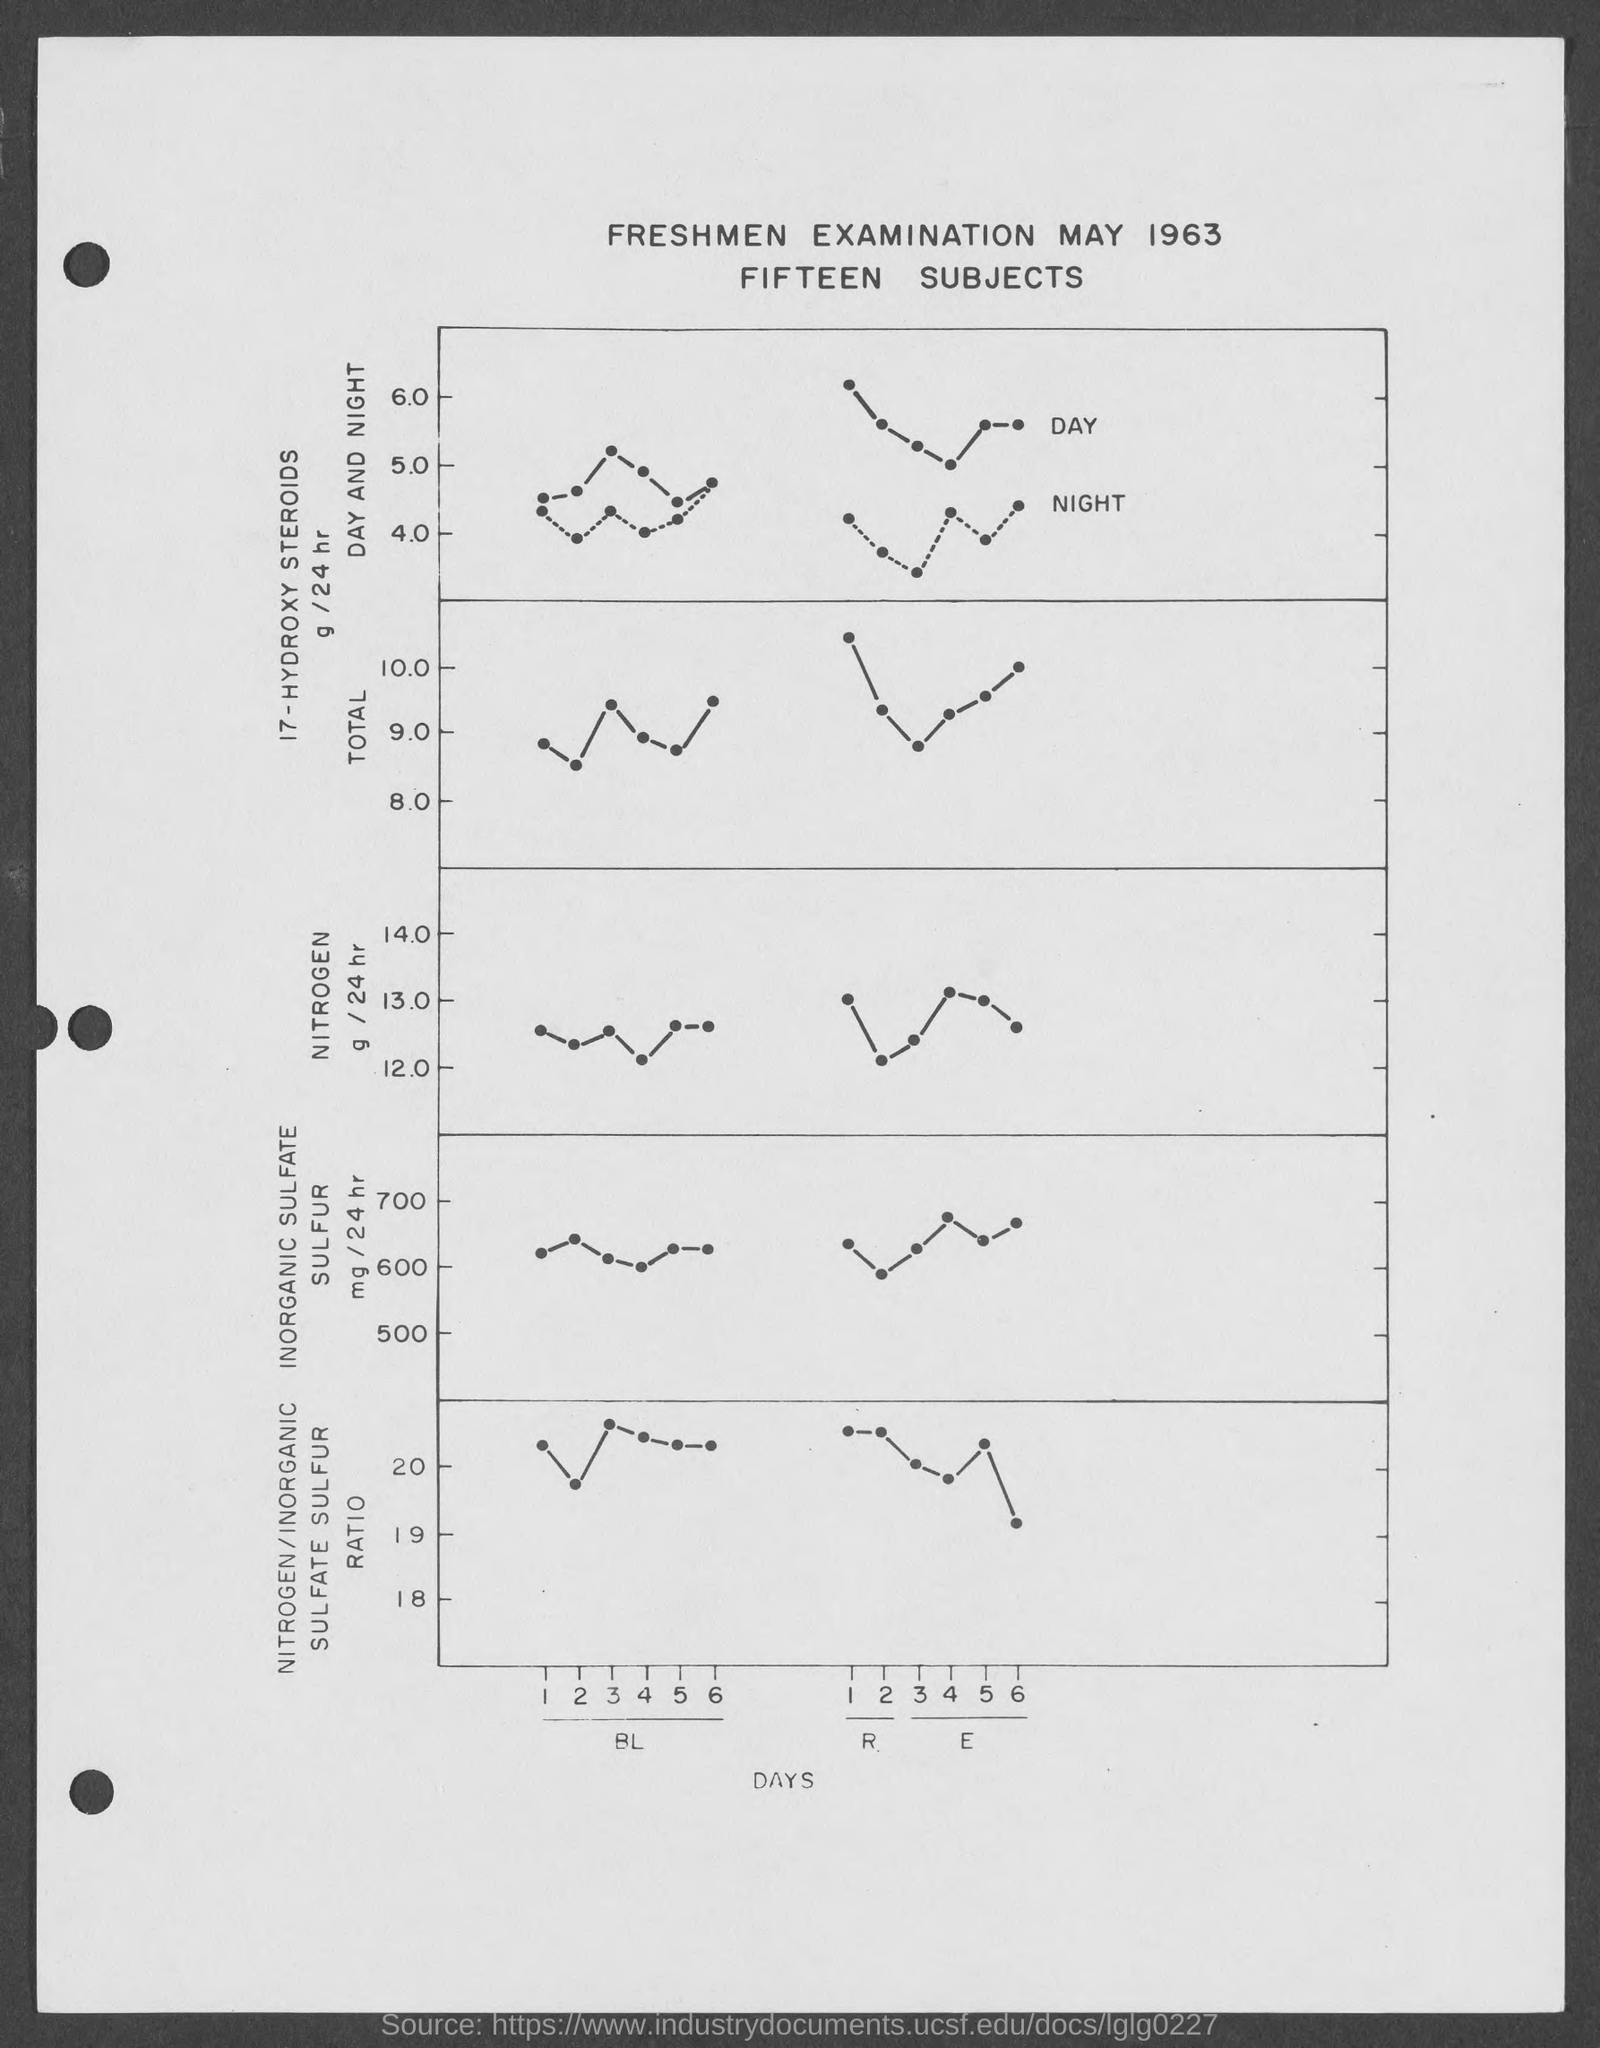Point out several critical features in this image. The heading of the plot is "Freshmen Examination May 1963. Fifteen subjects are mentioned in the heading. The x-axis in the plot refers to the days. 